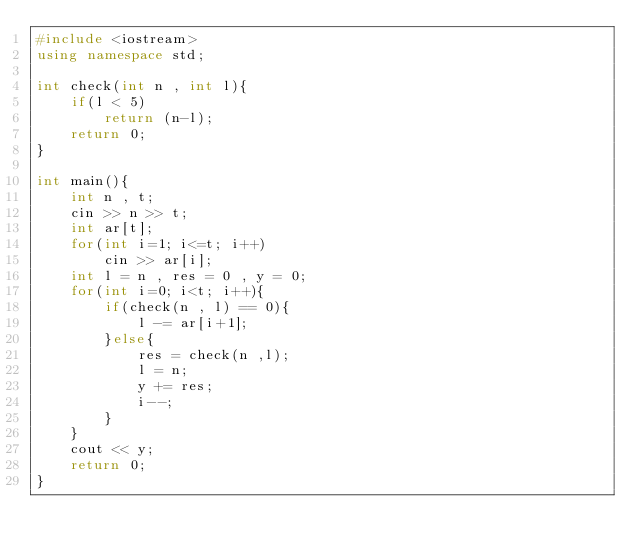Convert code to text. <code><loc_0><loc_0><loc_500><loc_500><_C++_>#include <iostream>
using namespace std;

int check(int n , int l){
    if(l < 5)
        return (n-l);
    return 0;
}

int main(){
    int n , t;
    cin >> n >> t;
    int ar[t];
    for(int i=1; i<=t; i++)
        cin >> ar[i];
    int l = n , res = 0 , y = 0;
    for(int i=0; i<t; i++){
        if(check(n , l) == 0){
            l -= ar[i+1];
        }else{
            res = check(n ,l);
            l = n;
            y += res;
            i--;
        }
    }
    cout << y;
    return 0;
}</code> 